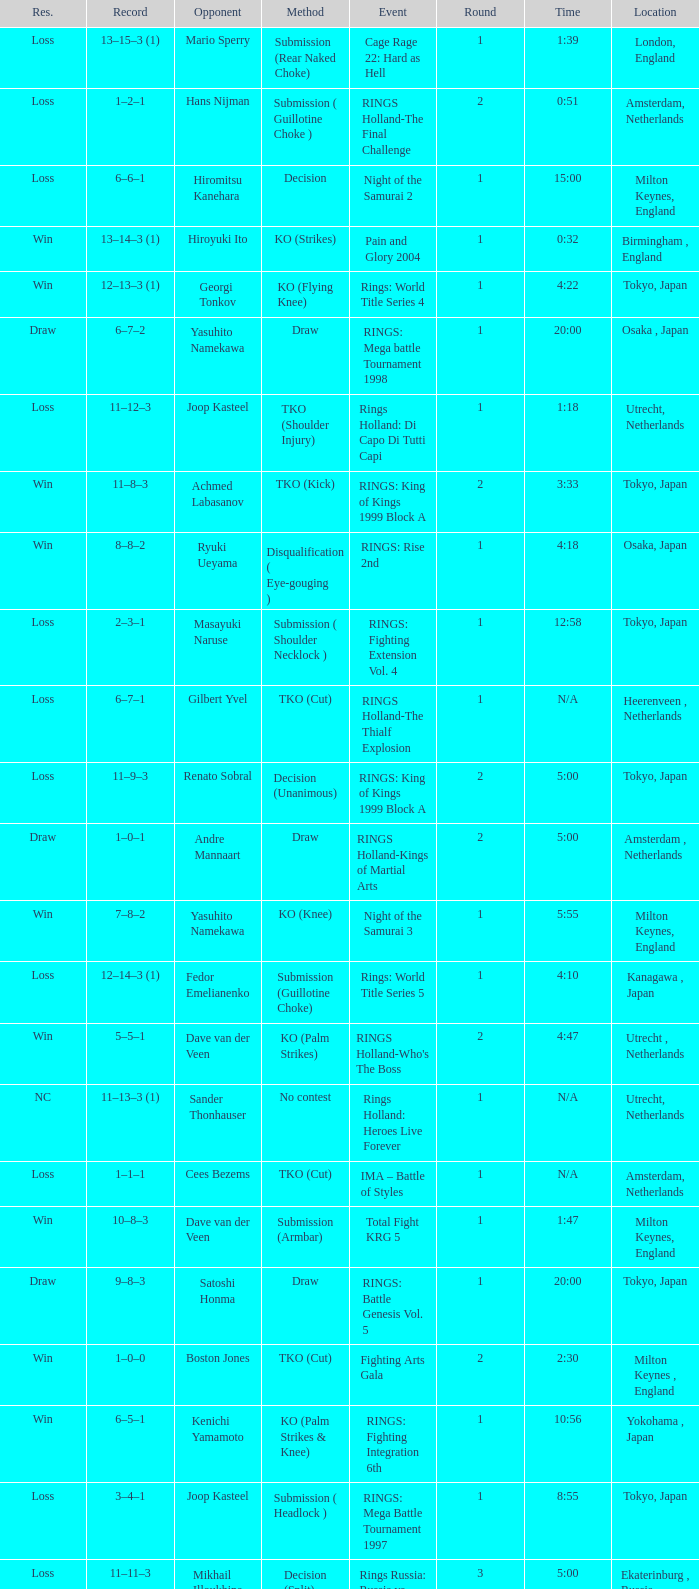Could you parse the entire table as a dict? {'header': ['Res.', 'Record', 'Opponent', 'Method', 'Event', 'Round', 'Time', 'Location'], 'rows': [['Loss', '13–15–3 (1)', 'Mario Sperry', 'Submission (Rear Naked Choke)', 'Cage Rage 22: Hard as Hell', '1', '1:39', 'London, England'], ['Loss', '1–2–1', 'Hans Nijman', 'Submission ( Guillotine Choke )', 'RINGS Holland-The Final Challenge', '2', '0:51', 'Amsterdam, Netherlands'], ['Loss', '6–6–1', 'Hiromitsu Kanehara', 'Decision', 'Night of the Samurai 2', '1', '15:00', 'Milton Keynes, England'], ['Win', '13–14–3 (1)', 'Hiroyuki Ito', 'KO (Strikes)', 'Pain and Glory 2004', '1', '0:32', 'Birmingham , England'], ['Win', '12–13–3 (1)', 'Georgi Tonkov', 'KO (Flying Knee)', 'Rings: World Title Series 4', '1', '4:22', 'Tokyo, Japan'], ['Draw', '6–7–2', 'Yasuhito Namekawa', 'Draw', 'RINGS: Mega battle Tournament 1998', '1', '20:00', 'Osaka , Japan'], ['Loss', '11–12–3', 'Joop Kasteel', 'TKO (Shoulder Injury)', 'Rings Holland: Di Capo Di Tutti Capi', '1', '1:18', 'Utrecht, Netherlands'], ['Win', '11–8–3', 'Achmed Labasanov', 'TKO (Kick)', 'RINGS: King of Kings 1999 Block A', '2', '3:33', 'Tokyo, Japan'], ['Win', '8–8–2', 'Ryuki Ueyama', 'Disqualification ( Eye-gouging )', 'RINGS: Rise 2nd', '1', '4:18', 'Osaka, Japan'], ['Loss', '2–3–1', 'Masayuki Naruse', 'Submission ( Shoulder Necklock )', 'RINGS: Fighting Extension Vol. 4', '1', '12:58', 'Tokyo, Japan'], ['Loss', '6–7–1', 'Gilbert Yvel', 'TKO (Cut)', 'RINGS Holland-The Thialf Explosion', '1', 'N/A', 'Heerenveen , Netherlands'], ['Loss', '11–9–3', 'Renato Sobral', 'Decision (Unanimous)', 'RINGS: King of Kings 1999 Block A', '2', '5:00', 'Tokyo, Japan'], ['Draw', '1–0–1', 'Andre Mannaart', 'Draw', 'RINGS Holland-Kings of Martial Arts', '2', '5:00', 'Amsterdam , Netherlands'], ['Win', '7–8–2', 'Yasuhito Namekawa', 'KO (Knee)', 'Night of the Samurai 3', '1', '5:55', 'Milton Keynes, England'], ['Loss', '12–14–3 (1)', 'Fedor Emelianenko', 'Submission (Guillotine Choke)', 'Rings: World Title Series 5', '1', '4:10', 'Kanagawa , Japan'], ['Win', '5–5–1', 'Dave van der Veen', 'KO (Palm Strikes)', "RINGS Holland-Who's The Boss", '2', '4:47', 'Utrecht , Netherlands'], ['NC', '11–13–3 (1)', 'Sander Thonhauser', 'No contest', 'Rings Holland: Heroes Live Forever', '1', 'N/A', 'Utrecht, Netherlands'], ['Loss', '1–1–1', 'Cees Bezems', 'TKO (Cut)', 'IMA – Battle of Styles', '1', 'N/A', 'Amsterdam, Netherlands'], ['Win', '10–8–3', 'Dave van der Veen', 'Submission (Armbar)', 'Total Fight KRG 5', '1', '1:47', 'Milton Keynes, England'], ['Draw', '9–8–3', 'Satoshi Honma', 'Draw', 'RINGS: Battle Genesis Vol. 5', '1', '20:00', 'Tokyo, Japan'], ['Win', '1–0–0', 'Boston Jones', 'TKO (Cut)', 'Fighting Arts Gala', '2', '2:30', 'Milton Keynes , England'], ['Win', '6–5–1', 'Kenichi Yamamoto', 'KO (Palm Strikes & Knee)', 'RINGS: Fighting Integration 6th', '1', '10:56', 'Yokohama , Japan'], ['Loss', '3–4–1', 'Joop Kasteel', 'Submission ( Headlock )', 'RINGS: Mega Battle Tournament 1997', '1', '8:55', 'Tokyo, Japan'], ['Loss', '11–11–3', 'Mikhail Illoukhine', 'Decision (Split)', 'Rings Russia: Russia vs. The World', '3', '5:00', 'Ekaterinburg , Russia'], ['Win', '3–3–1', 'Peter Dijkman', 'Submission ( Rear Naked Choke )', 'Total Fight Night', '1', '4:46', 'Milton Keynes, England'], ['Loss', '13–16–3 (1)', 'Ivan Serati', 'Submission (Rear Naked Choke)', 'Cage Rage 24: Feel the Pain', '2', '1:34', 'London, England'], ['Loss', '11–10–3', 'Mikhail Avetisyan', 'Submission (Strikes)', 'IAFC – Pankration World Championship 2000 (Day 2)', '1', 'N/A', 'Moscow, Russia'], ['Win', '2–2–1', 'Sean McCully', 'Submission (Guillotine Choke)', 'RINGS: Battle Genesis Vol. 1', '1', '3:59', 'Tokyo, Japan'], ['Loss', '6–8–2', 'Yasuhito Namekawa', 'Decision', 'RINGS: Mega battle Tournament 1998', '1', '20:00', 'Tokyo, Japan'], ['Loss', '11–13–3', 'Volk Han', 'TKO (Eye Injury)', 'Rings: King of Kings 2000 Block B', '2', '0:08', 'Osaka, Japan'], ['Win', '4–4–1', 'Sander Thonhauser', 'Submission ( Armbar )', 'Night of the Samurai 1', '1', '0:55', 'Milton Keynes, England'], ['Loss', '4–5–1', 'Hiromitsu Kanehara', 'Decision', 'RINGS: Fighting Integration 3rd', '1', '30:00', 'Sapporo , Japan'], ['Win', '9–8–2', 'Ricardo Fyeet', 'Submission ( Toe Hold )', 'RINGS: Rise 5th', '1', '15:01', 'Yokohama, Japan']]} What is the time for Moscow, Russia? N/A. 